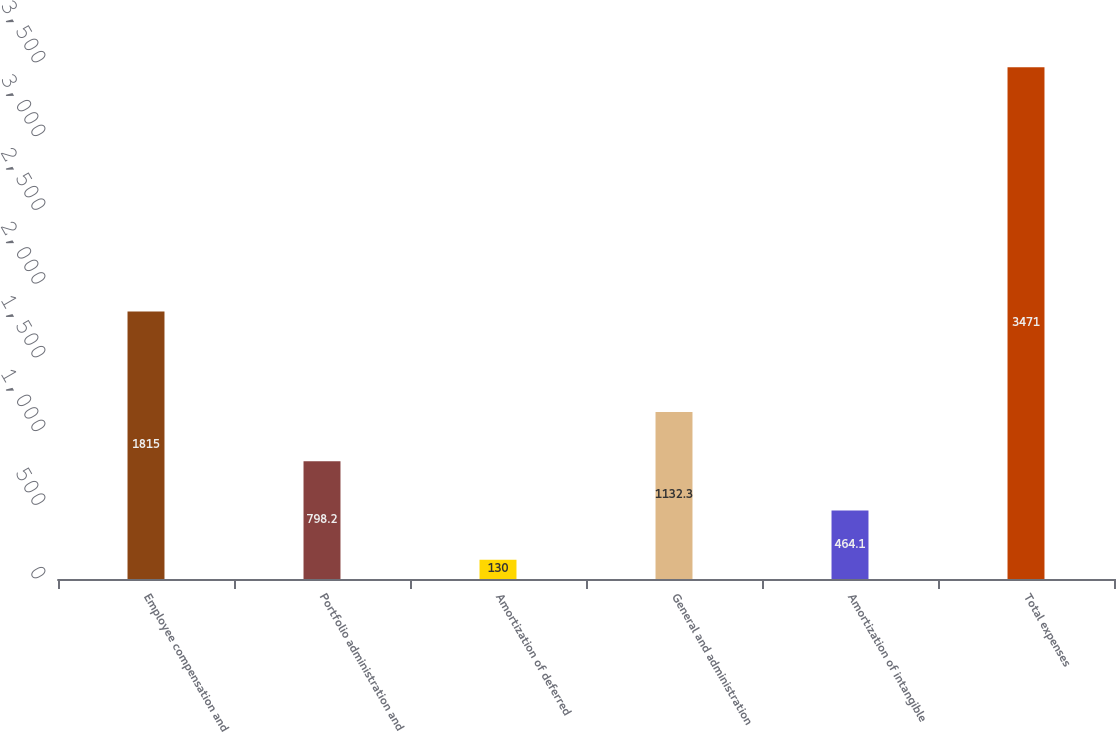<chart> <loc_0><loc_0><loc_500><loc_500><bar_chart><fcel>Employee compensation and<fcel>Portfolio administration and<fcel>Amortization of deferred<fcel>General and administration<fcel>Amortization of intangible<fcel>Total expenses<nl><fcel>1815<fcel>798.2<fcel>130<fcel>1132.3<fcel>464.1<fcel>3471<nl></chart> 